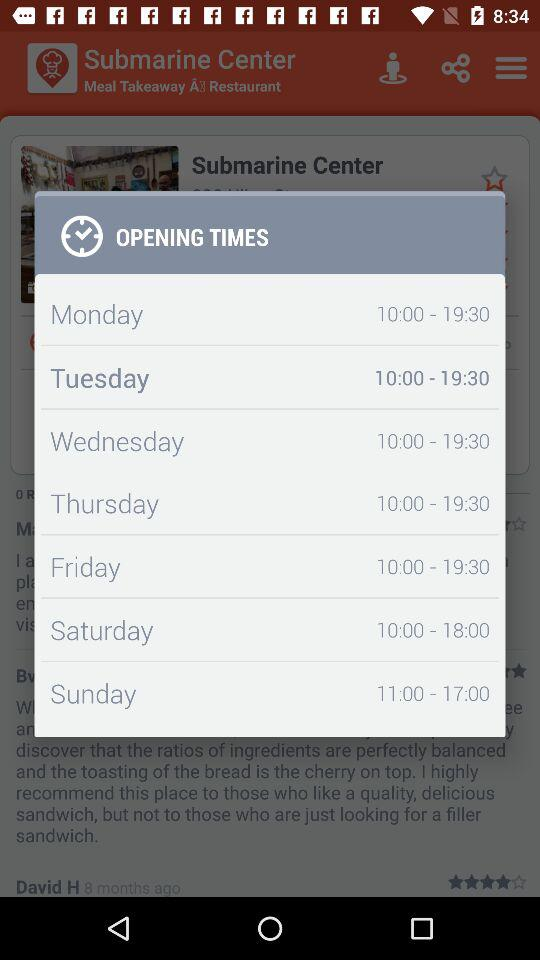What is the opening time of the selected day? The opening time of the selected day is 10:00. 